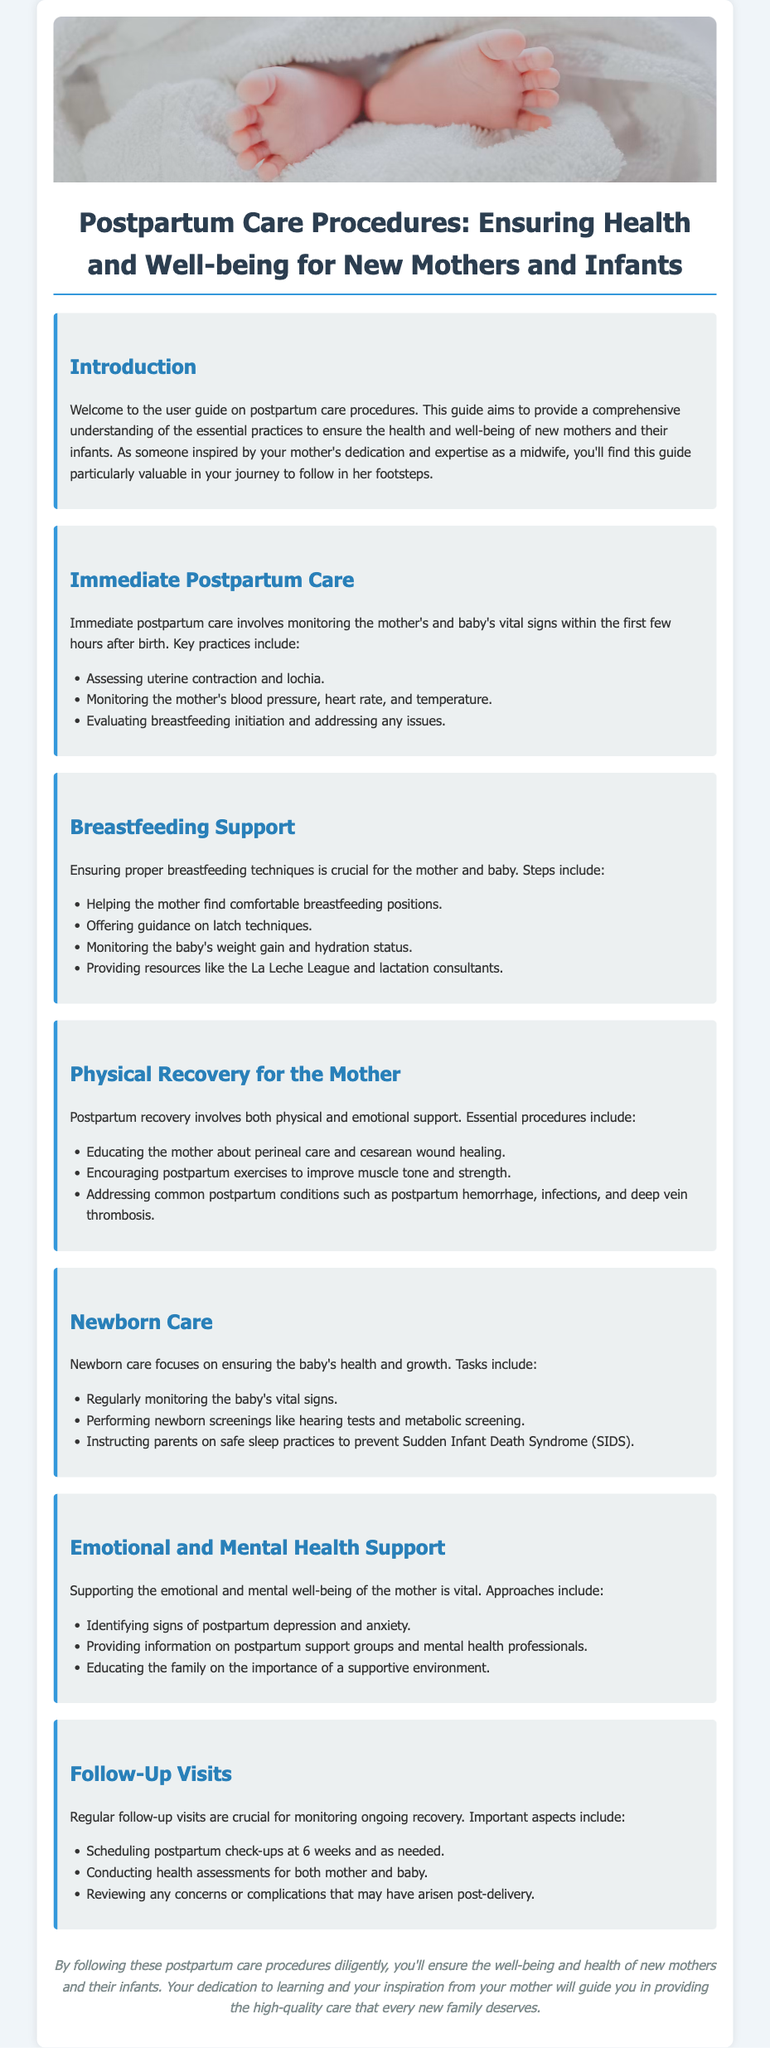What are the vital signs to monitor in the immediate postpartum care? The section on Immediate Postpartum Care lists monitoring the mother's blood pressure, heart rate, and temperature as vital signs.
Answer: Blood pressure, heart rate, temperature What should be monitored in the baby during breastfeeding support? The guide mentions monitoring the baby's weight gain and hydration status as part of the breastfeeding support.
Answer: Weight gain and hydration status What are two essential procedures for the mother's physical recovery? The Physical Recovery for the Mother section mentions educating the mother about perineal care and encouraging postpartum exercises.
Answer: Perineal care and postpartum exercises What screenings are performed for newborns? The Newborn Care section specifies performing newborn screenings like hearing tests and metabolic screening.
Answer: Hearing tests and metabolic screening What is the timeframe for scheduling postpartum check-ups? The Follow-Up Visits section states that postpartum check-ups should be scheduled at 6 weeks and as needed.
Answer: 6 weeks What emotional support should be identified for mothers? The Emotional and Mental Health Support section identifies signs of postpartum depression and anxiety as important aspects of support.
Answer: Postpartum depression and anxiety Which organization is mentioned for breastfeeding resources? The Breastfeeding Support section references the La Leche League as a resource for breastfeeding support.
Answer: La Leche League What is a key focus of newborn care? The Newborn Care section emphasizes regularly monitoring the baby's vital signs as a key focus.
Answer: Monitoring vital signs What type of environment is encouraged for supporting the mother? The Emotional and Mental Health Support section discusses the importance of a supportive environment for the mother.
Answer: Supportive environment 